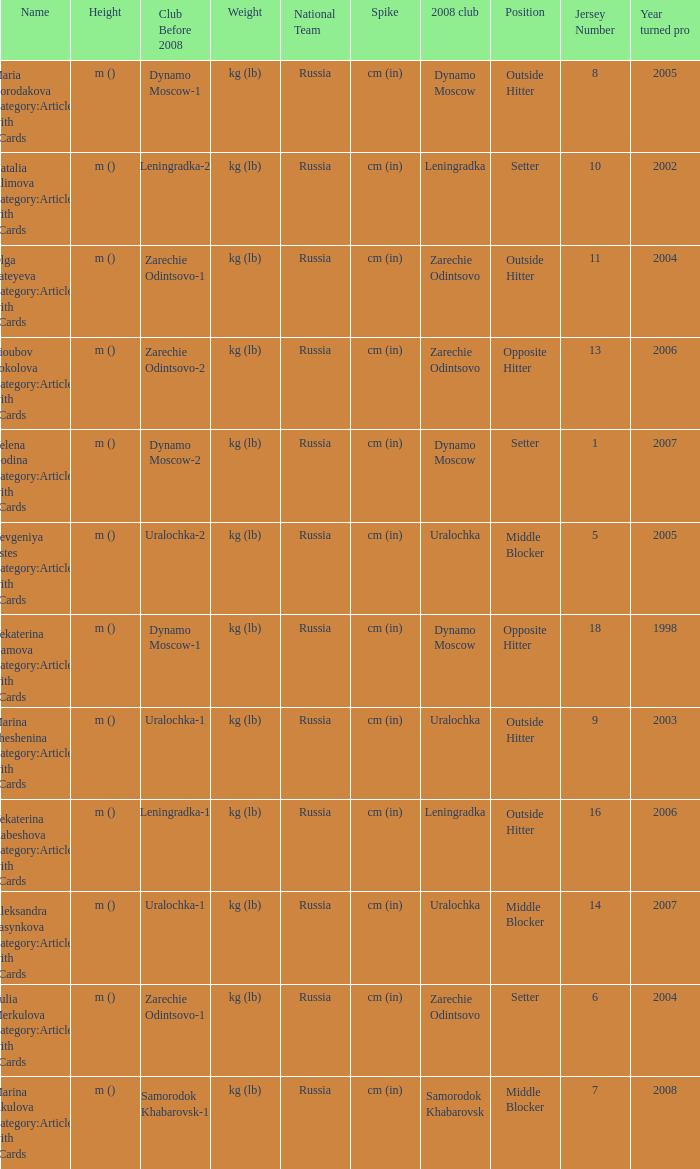What is the name when the 2008 club is uralochka? Yevgeniya Estes Category:Articles with hCards, Marina Sheshenina Category:Articles with hCards, Aleksandra Pasynkova Category:Articles with hCards. 